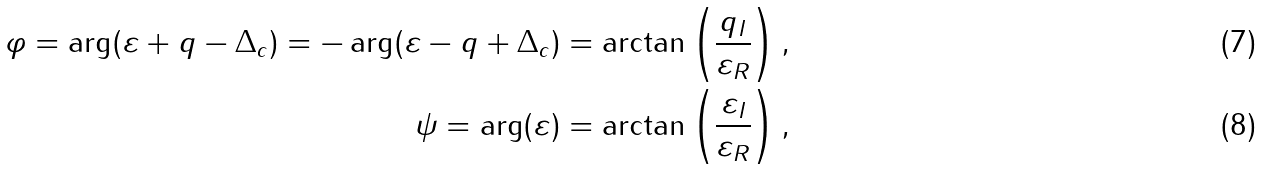<formula> <loc_0><loc_0><loc_500><loc_500>\varphi = \arg ( \varepsilon + q - \Delta _ { c } ) = - \arg ( \varepsilon - q + \Delta _ { c } ) = \arctan \left ( \frac { q _ { I } } { \varepsilon _ { R } } \right ) , \\ \psi = \arg ( \varepsilon ) = \arctan \left ( \frac { \varepsilon _ { I } } { \varepsilon _ { R } } \right ) ,</formula> 